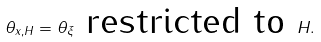<formula> <loc_0><loc_0><loc_500><loc_500>\theta _ { x , H } = \theta _ { \xi } \text { restricted to } H .</formula> 